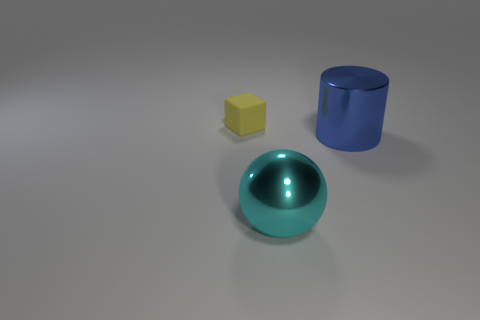Is there any indication of the size scale of these objects? Without reference objects of a known size, it's difficult to determine the scale with certainty. However, given the simplicity of the shapes and lack of additional context, they might represent relatively small objects that could fit on a table, rather than being large industrial items or tiny micro-components. 